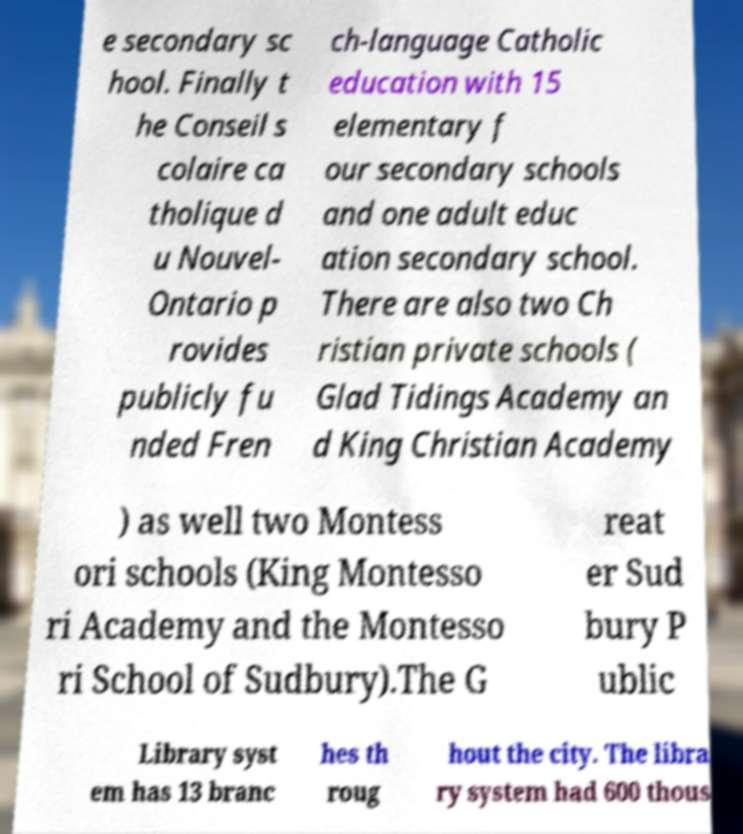What messages or text are displayed in this image? I need them in a readable, typed format. e secondary sc hool. Finally t he Conseil s colaire ca tholique d u Nouvel- Ontario p rovides publicly fu nded Fren ch-language Catholic education with 15 elementary f our secondary schools and one adult educ ation secondary school. There are also two Ch ristian private schools ( Glad Tidings Academy an d King Christian Academy ) as well two Montess ori schools (King Montesso ri Academy and the Montesso ri School of Sudbury).The G reat er Sud bury P ublic Library syst em has 13 branc hes th roug hout the city. The libra ry system had 600 thous 